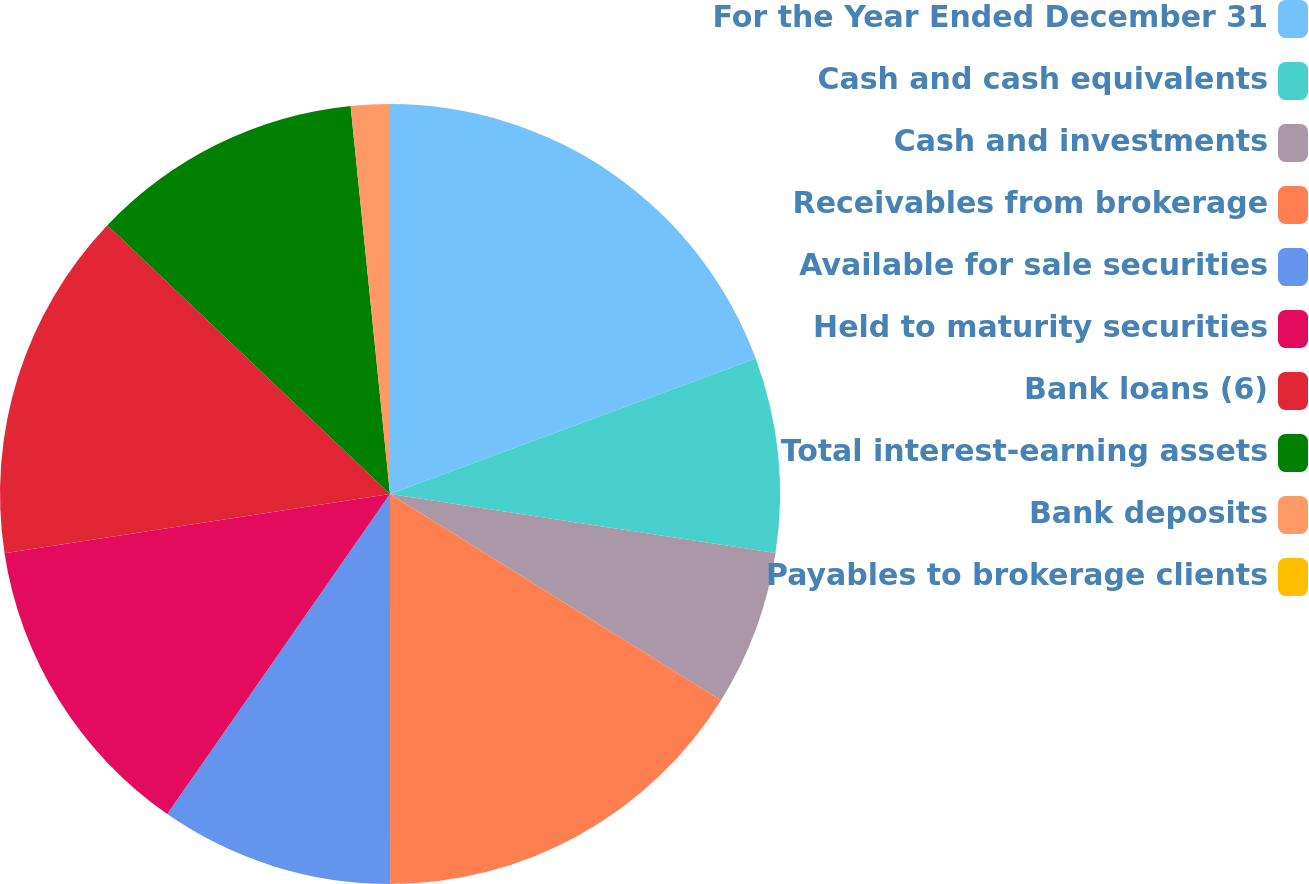Convert chart. <chart><loc_0><loc_0><loc_500><loc_500><pie_chart><fcel>For the Year Ended December 31<fcel>Cash and cash equivalents<fcel>Cash and investments<fcel>Receivables from brokerage<fcel>Available for sale securities<fcel>Held to maturity securities<fcel>Bank loans (6)<fcel>Total interest-earning assets<fcel>Bank deposits<fcel>Payables to brokerage clients<nl><fcel>19.35%<fcel>8.06%<fcel>6.45%<fcel>16.13%<fcel>9.68%<fcel>12.9%<fcel>14.52%<fcel>11.29%<fcel>1.61%<fcel>0.0%<nl></chart> 